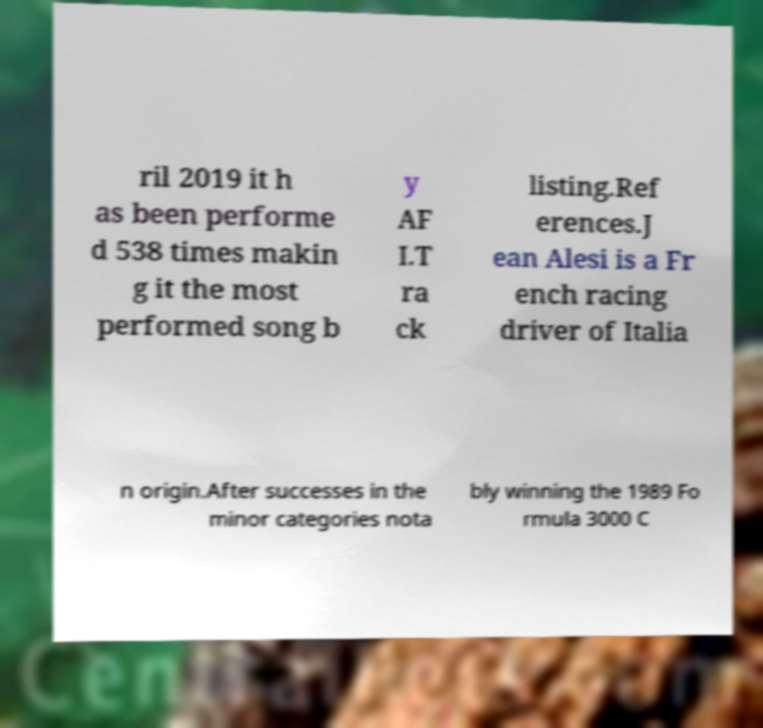What messages or text are displayed in this image? I need them in a readable, typed format. ril 2019 it h as been performe d 538 times makin g it the most performed song b y AF I.T ra ck listing.Ref erences.J ean Alesi is a Fr ench racing driver of Italia n origin.After successes in the minor categories nota bly winning the 1989 Fo rmula 3000 C 